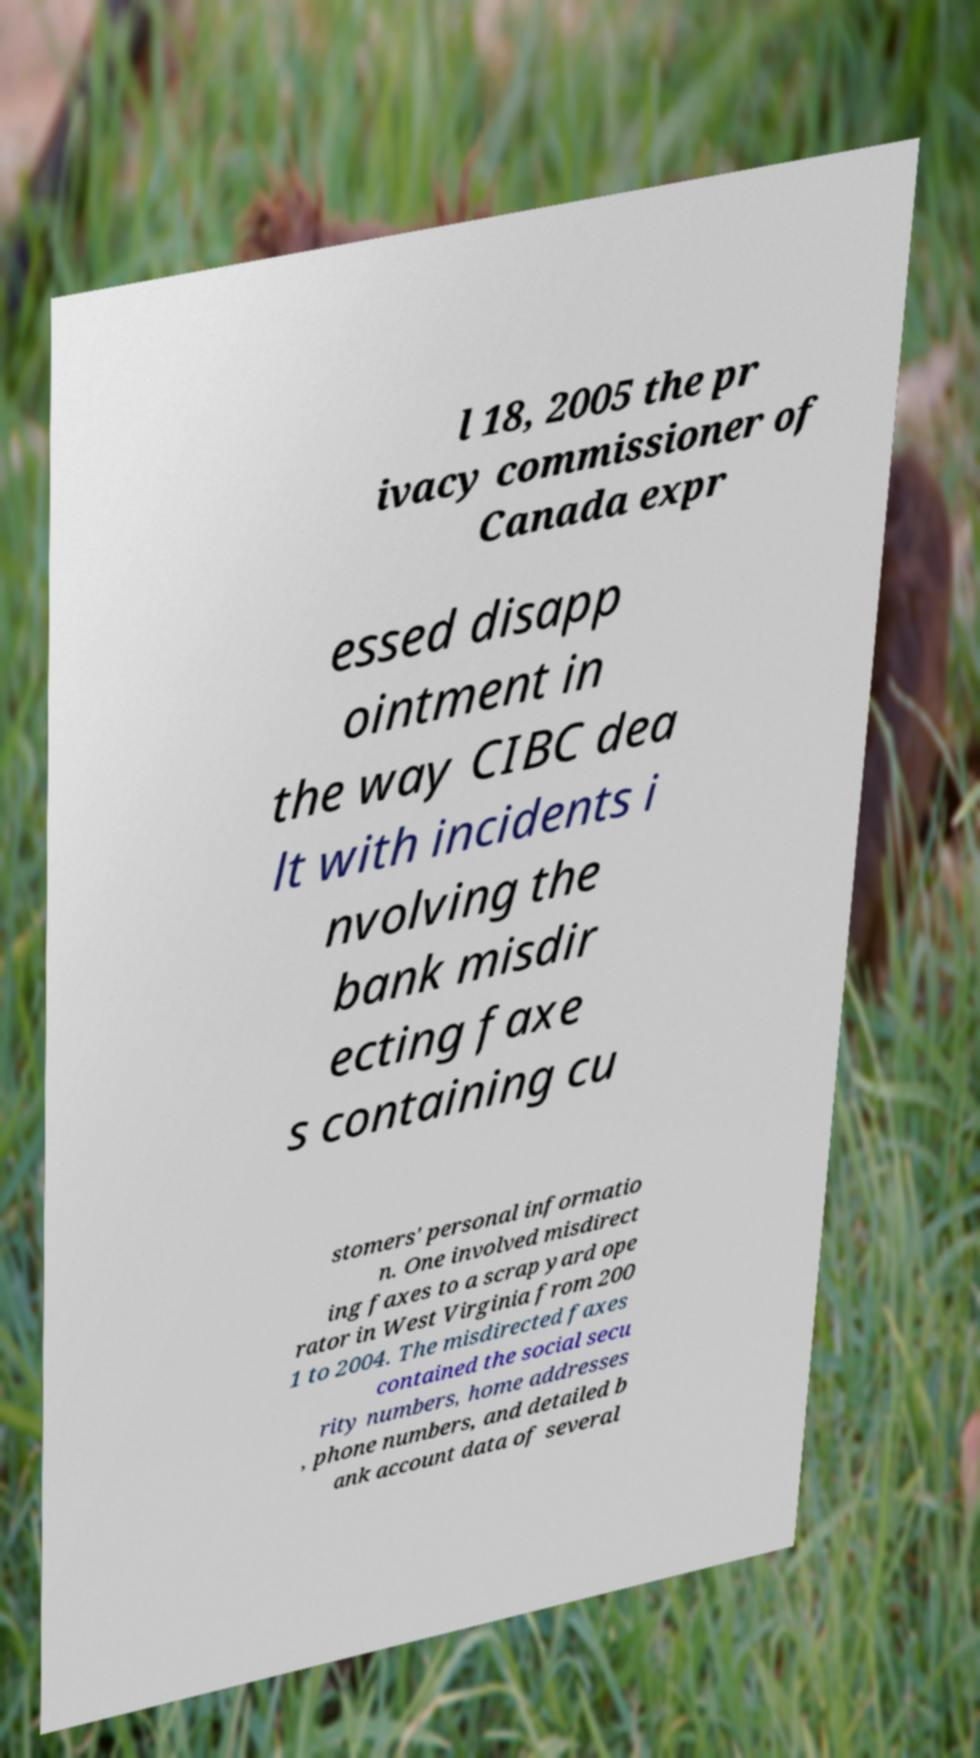What messages or text are displayed in this image? I need them in a readable, typed format. l 18, 2005 the pr ivacy commissioner of Canada expr essed disapp ointment in the way CIBC dea lt with incidents i nvolving the bank misdir ecting faxe s containing cu stomers' personal informatio n. One involved misdirect ing faxes to a scrap yard ope rator in West Virginia from 200 1 to 2004. The misdirected faxes contained the social secu rity numbers, home addresses , phone numbers, and detailed b ank account data of several 